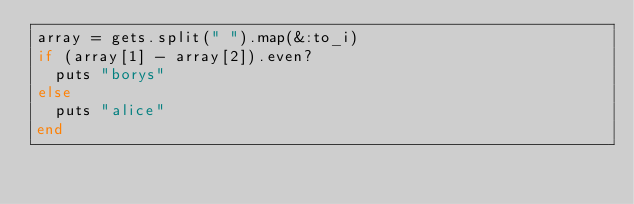Convert code to text. <code><loc_0><loc_0><loc_500><loc_500><_Ruby_>array = gets.split(" ").map(&:to_i)
if (array[1] - array[2]).even?
  puts "borys"
else
  puts "alice"
end</code> 